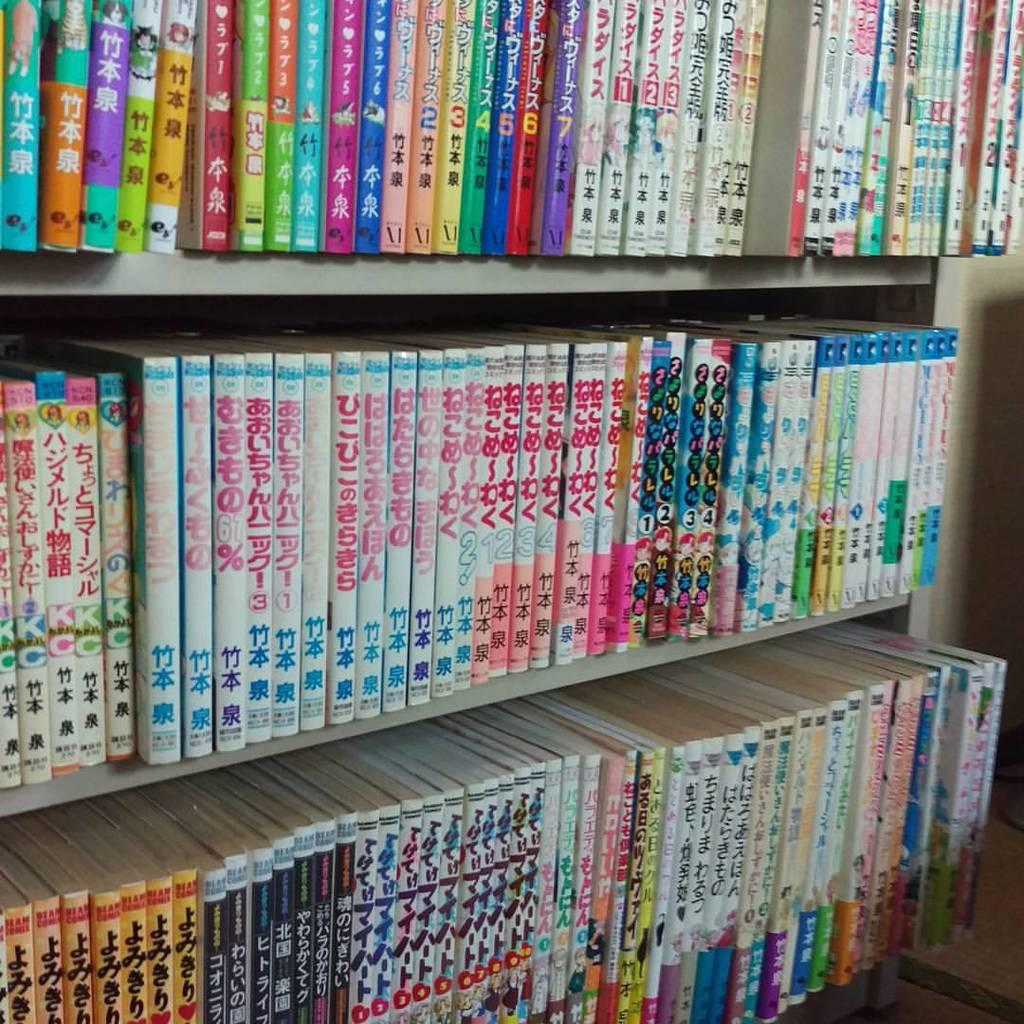What can be seen on the racks in the image? There are books on racks in the image. What is located on the right side of the image? There is a wall on the right side of the image. What surface is visible in the image? There is a floor visible in the image. What arithmetic problem is being solved by the man in the image? There is no man present in the image, and therefore no arithmetic problem being solved. 